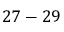<formula> <loc_0><loc_0><loc_500><loc_500>2 7 - 2 9</formula> 